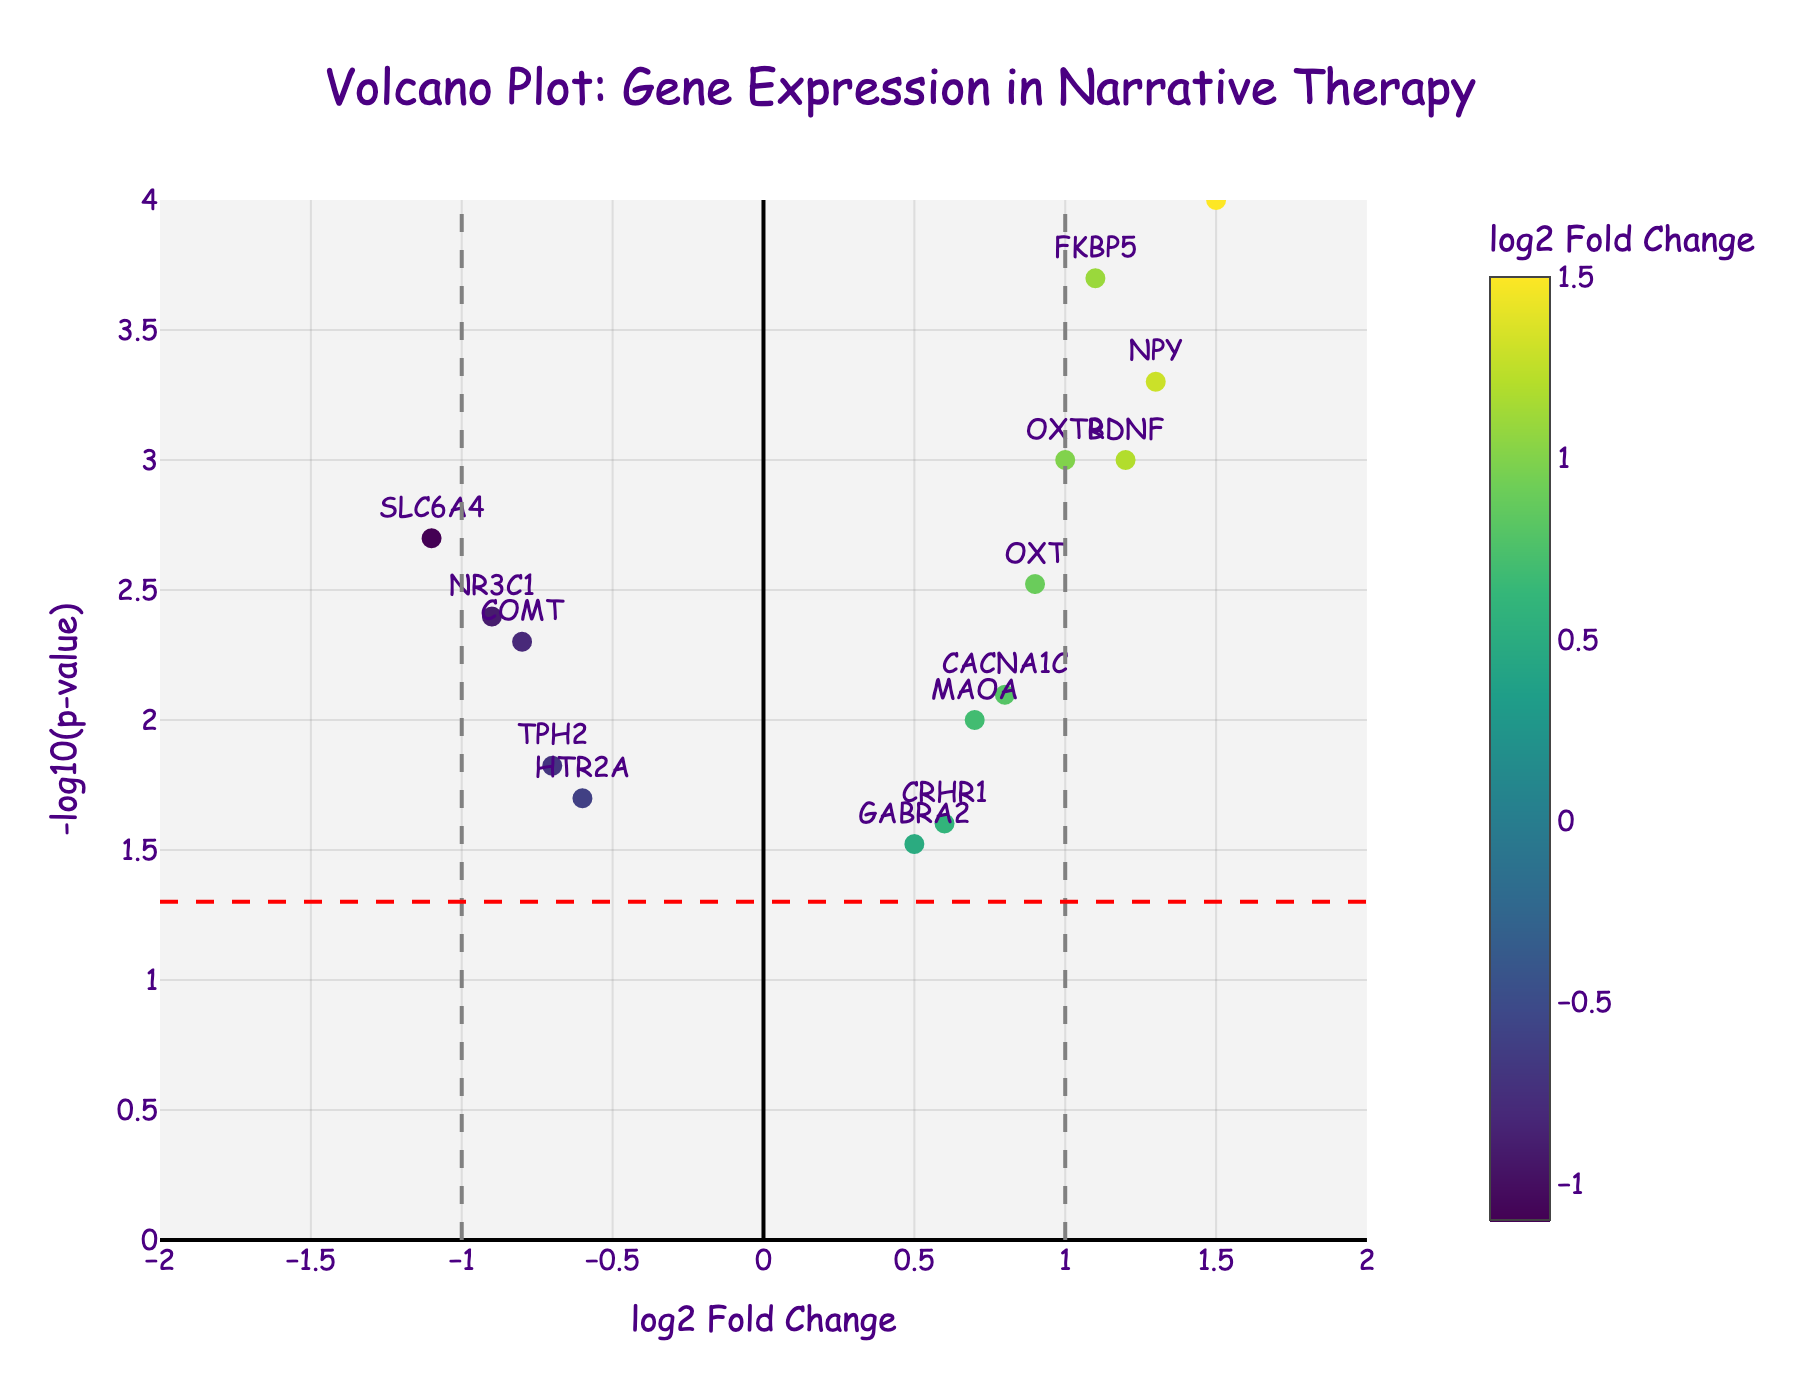Which gene has the highest log2 fold change? The log2 fold change is on the x-axis. The highest value on the x-axis representing a gene is DRD2 with a log2 fold change of 1.5.
Answer: DRD2 Which gene has the lowest p-value? The p-value is represented by the y-axis as -log10(p-value). The higher the value on the y-axis, the lower the p-value. DRD2 has the highest value on the y-axis, indicating it has the lowest p-value (0.0001).
Answer: DRD2 How many genes have a positive log2 fold change and a p-value less than 0.05? Positive log2 fold change values are greater than 0 on the x-axis. A p-value less than 0.05 corresponds to a y-axis value greater than -log10(0.05). The genes that meet these criteria are BDNF, OXT, DRD2, NPY, OXTR, CACNA1C, and FKBP5. Counting these entries, we get 7 genes.
Answer: 7 Which gene is closest to having a log2 fold change of 0 and what’s its p-value? The x-axis represents the log2 fold change, and the closest value to 0 on the x-axis is GABRA2 with a log2 fold change of 0.5. Its corresponding p-value is 0.03.
Answer: GABRA2, 0.03 Which genes have a log2 fold change less than -0.5 and a p-value greater than 0.01? A log2 fold change less than -0.5 corresponds to values on the x-axis less than -0.5. A p-value greater than 0.01 corresponds to values on the y-axis less than -log10(0.01). Inspecting the data, HTR2A has a log2 fold change of -0.6 and a p-value of 0.02.
Answer: HTR2A What is the log2 fold change and p-value of SLC6A4? The data gives the log2 fold change for SLC6A4 as -1.1 and its p-value as 0.002.
Answer: -1.1, 0.002 Which gene has a log2 fold change of 1.3? The log2 fold change of 1.3 is represented on the x-axis, and the corresponding gene is NPY.
Answer: NPY What’s the approximate y-axis value for the p-value threshold of 0.05? The p-value threshold of 0.05 corresponds to its negative log10 value on the y-axis: -log10(0.05). This results in approximately 1.3 on the y-axis.
Answer: 1.3 